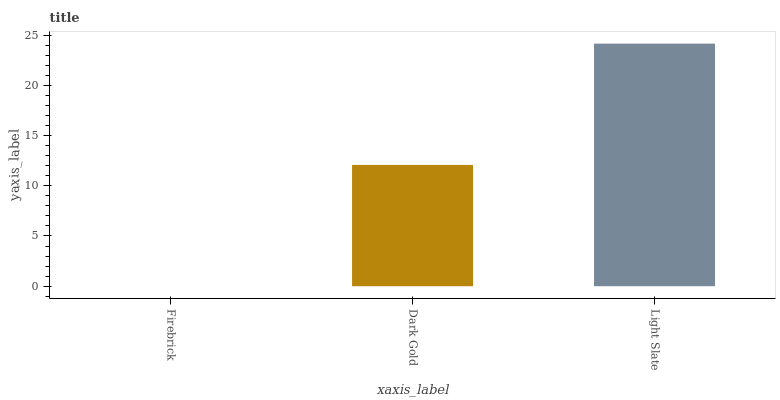Is Firebrick the minimum?
Answer yes or no. Yes. Is Light Slate the maximum?
Answer yes or no. Yes. Is Dark Gold the minimum?
Answer yes or no. No. Is Dark Gold the maximum?
Answer yes or no. No. Is Dark Gold greater than Firebrick?
Answer yes or no. Yes. Is Firebrick less than Dark Gold?
Answer yes or no. Yes. Is Firebrick greater than Dark Gold?
Answer yes or no. No. Is Dark Gold less than Firebrick?
Answer yes or no. No. Is Dark Gold the high median?
Answer yes or no. Yes. Is Dark Gold the low median?
Answer yes or no. Yes. Is Firebrick the high median?
Answer yes or no. No. Is Firebrick the low median?
Answer yes or no. No. 